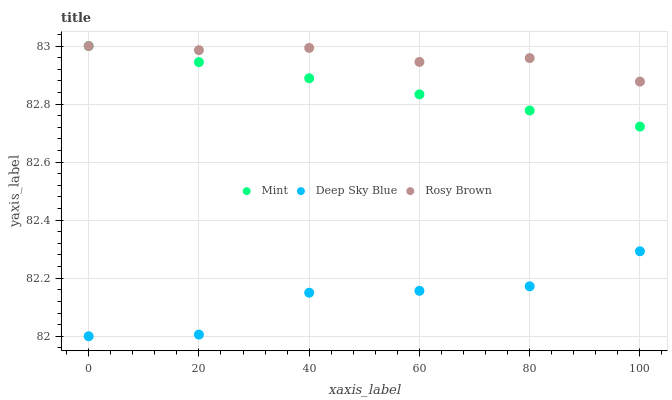Does Deep Sky Blue have the minimum area under the curve?
Answer yes or no. Yes. Does Rosy Brown have the maximum area under the curve?
Answer yes or no. Yes. Does Mint have the minimum area under the curve?
Answer yes or no. No. Does Mint have the maximum area under the curve?
Answer yes or no. No. Is Mint the smoothest?
Answer yes or no. Yes. Is Deep Sky Blue the roughest?
Answer yes or no. Yes. Is Deep Sky Blue the smoothest?
Answer yes or no. No. Is Mint the roughest?
Answer yes or no. No. Does Deep Sky Blue have the lowest value?
Answer yes or no. Yes. Does Mint have the lowest value?
Answer yes or no. No. Does Mint have the highest value?
Answer yes or no. Yes. Does Deep Sky Blue have the highest value?
Answer yes or no. No. Is Deep Sky Blue less than Mint?
Answer yes or no. Yes. Is Mint greater than Deep Sky Blue?
Answer yes or no. Yes. Does Mint intersect Rosy Brown?
Answer yes or no. Yes. Is Mint less than Rosy Brown?
Answer yes or no. No. Is Mint greater than Rosy Brown?
Answer yes or no. No. Does Deep Sky Blue intersect Mint?
Answer yes or no. No. 